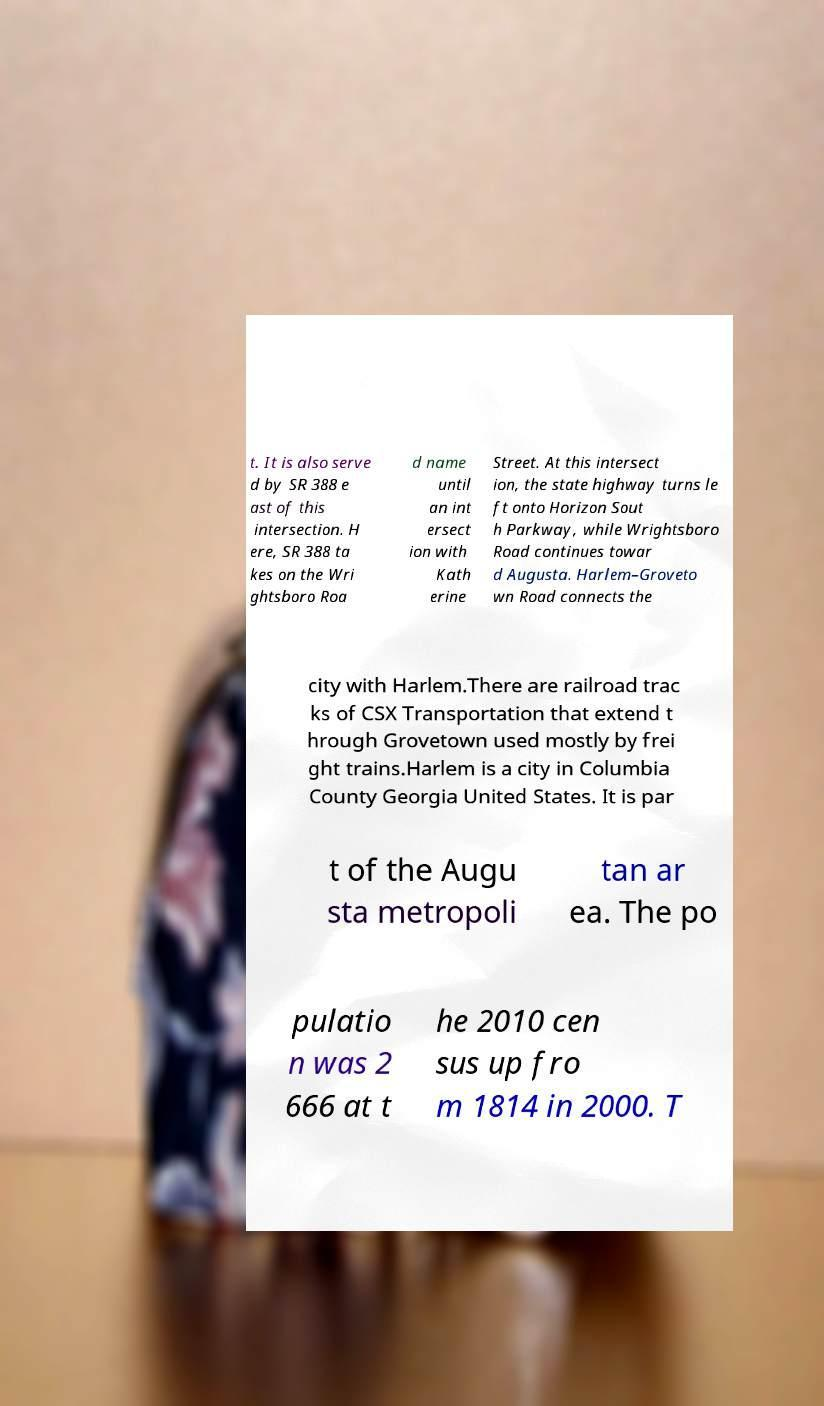Please read and relay the text visible in this image. What does it say? t. It is also serve d by SR 388 e ast of this intersection. H ere, SR 388 ta kes on the Wri ghtsboro Roa d name until an int ersect ion with Kath erine Street. At this intersect ion, the state highway turns le ft onto Horizon Sout h Parkway, while Wrightsboro Road continues towar d Augusta. Harlem–Groveto wn Road connects the city with Harlem.There are railroad trac ks of CSX Transportation that extend t hrough Grovetown used mostly by frei ght trains.Harlem is a city in Columbia County Georgia United States. It is par t of the Augu sta metropoli tan ar ea. The po pulatio n was 2 666 at t he 2010 cen sus up fro m 1814 in 2000. T 